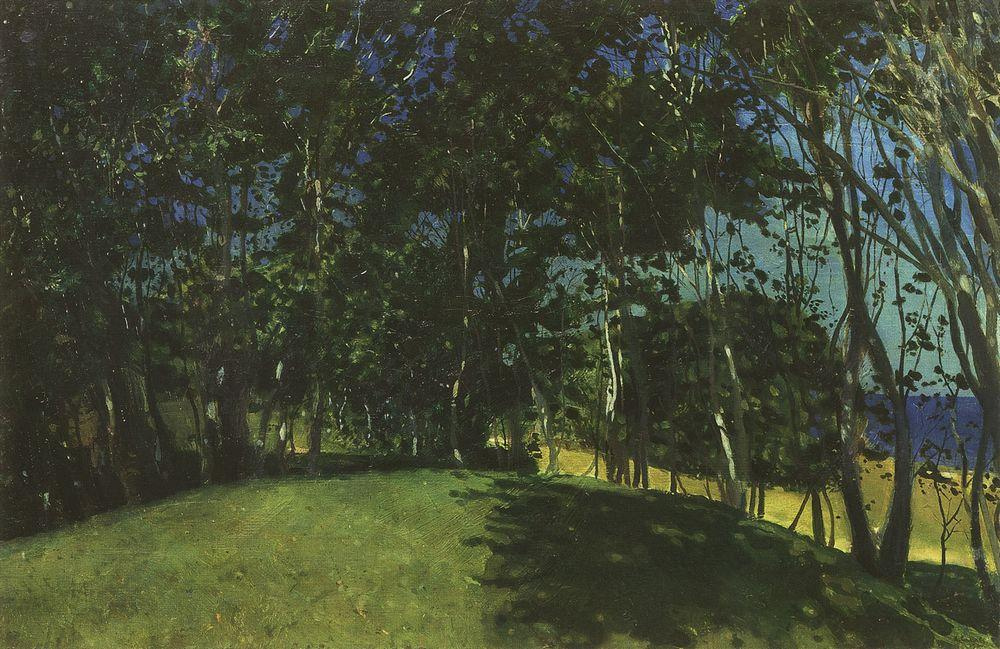What might the deeper symbolism in the painting suggest about the artist's intentions? The composition and mood of the painting might suggest themes of solitude, reflection, or connection with nature. The secluded path through dense trees could symbolize a journey or a passage, both literally through the woods and metaphorically through one's inner thoughts or emotions. This interpretation points to the artist's likely intention to evoke contemplation and a deep appreciation of nature's quiet beauty. How does the chosen perspective influence the viewer's interaction with the painting? The artist's choice to position the path centrally and lead it inward through the trees draws the viewer's eye deep into the scene, effectively inviting them into the landscape. This technique enhances the feeling of immersion, making the viewer feel as if they are part of the environment, experiencing its tranquility firsthand. 